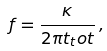Convert formula to latex. <formula><loc_0><loc_0><loc_500><loc_500>f = \frac { \kappa } { 2 \pi t _ { t } o t } \, ,</formula> 